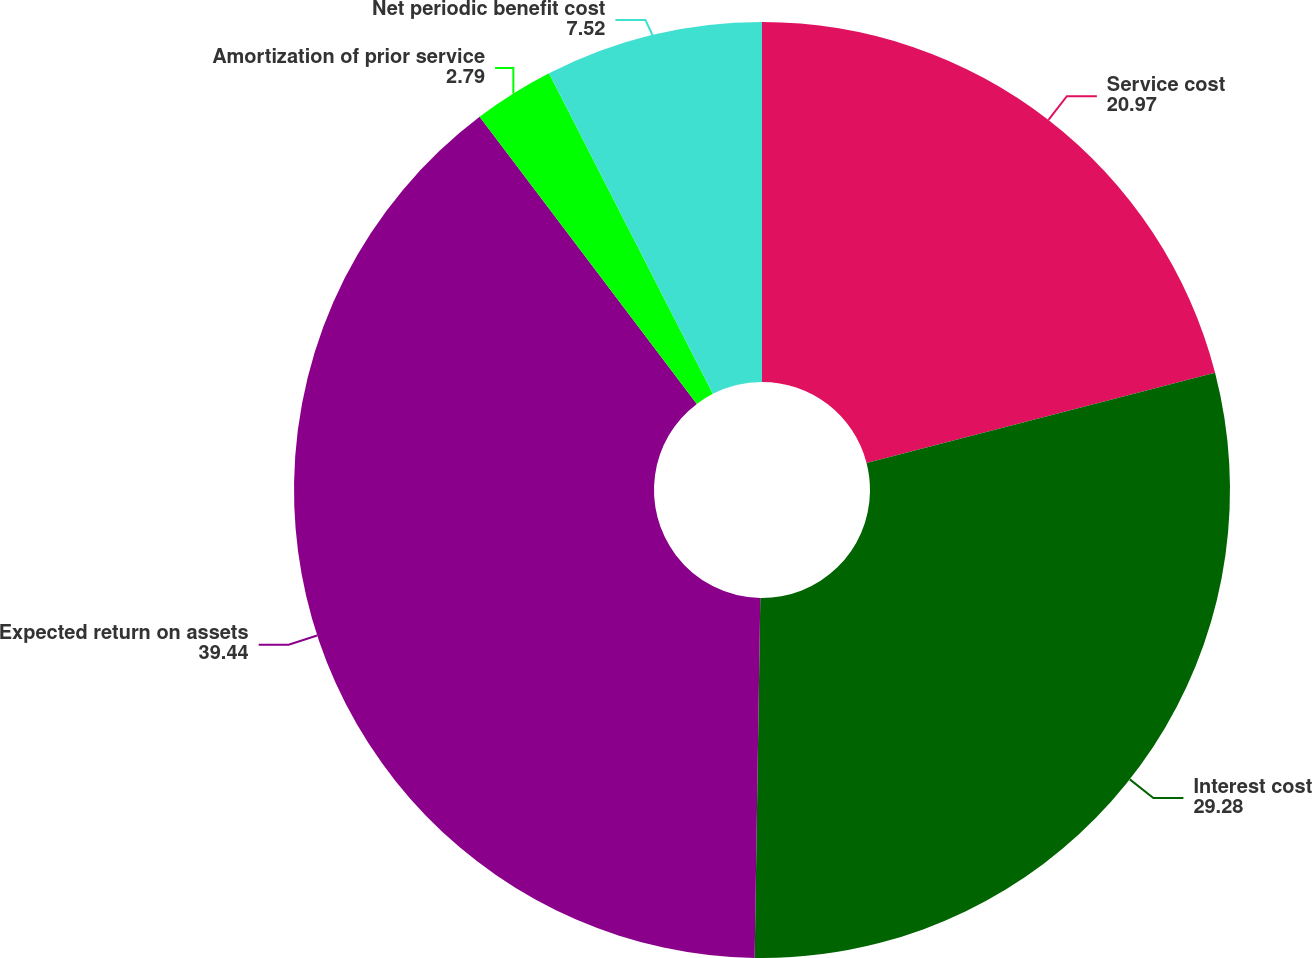Convert chart to OTSL. <chart><loc_0><loc_0><loc_500><loc_500><pie_chart><fcel>Service cost<fcel>Interest cost<fcel>Expected return on assets<fcel>Amortization of prior service<fcel>Net periodic benefit cost<nl><fcel>20.97%<fcel>29.28%<fcel>39.44%<fcel>2.79%<fcel>7.52%<nl></chart> 